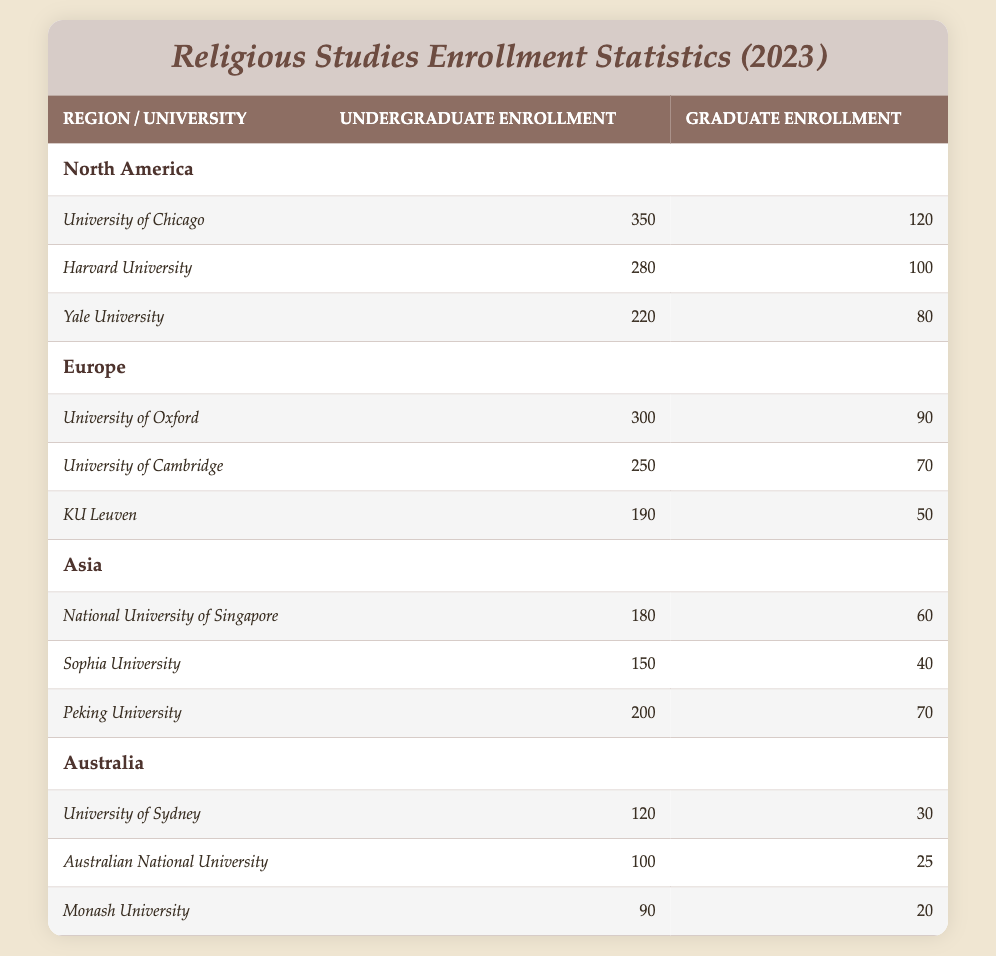What is the total undergraduate enrollment for religious studies programs in North America? To calculate the total undergraduate enrollment in North America, we add the undergraduate enrollments of the three universities: University of Chicago (350), Harvard University (280), and Yale University (220). The total is 350 + 280 + 220 = 850.
Answer: 850 Which university in Europe has the highest graduate enrollment? Using the data from Europe, we can compare the graduate enrollment numbers: University of Oxford (90), University of Cambridge (70), and KU Leuven (50). The highest number is from the University of Oxford with 90 graduate students.
Answer: University of Oxford Is the undergraduate enrollment at Sophia University greater than that at KULeuven? Sophia University has 150 undergraduate students while KULeuven has 190. Since 150 is less than 190, the statement is false.
Answer: No What is the total graduate enrollment across all universities in Australia? To find the total graduate enrollment in Australia, add the graduate enrollments of the universities: University of Sydney (30), Australian National University (25), and Monash University (20). The total is 30 + 25 + 20 = 75.
Answer: 75 What is the average undergraduate enrollment in Asia? To find the average undergraduate enrollment in Asia, we first sum the enrollments: National University of Singapore (180), Sophia University (150), and Peking University (200). The total is 180 + 150 + 200 = 530. There are 3 universities, so the average is 530 / 3 ≈ 176.67.
Answer: 176.67 